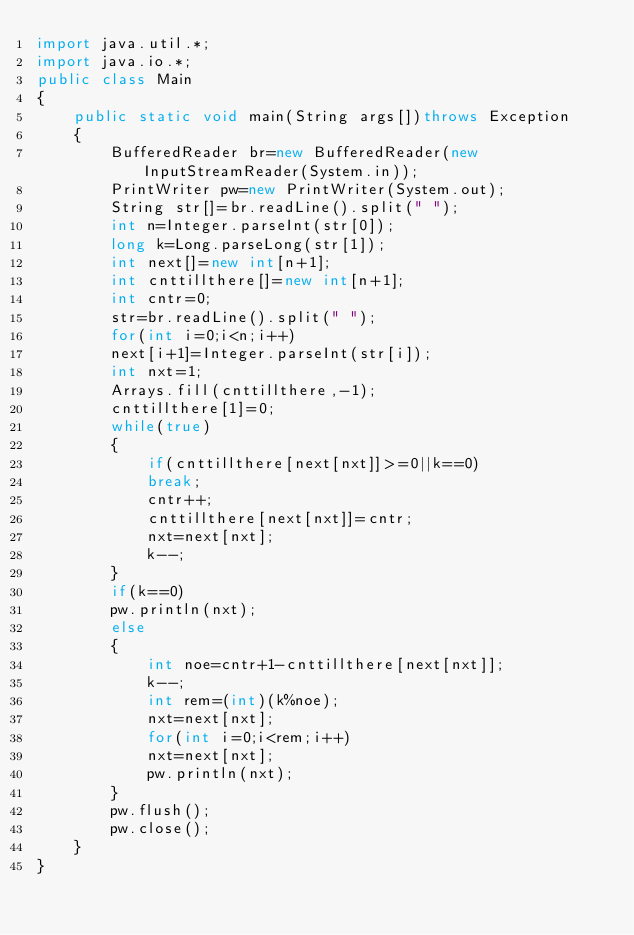Convert code to text. <code><loc_0><loc_0><loc_500><loc_500><_Java_>import java.util.*;
import java.io.*;
public class Main
{
    public static void main(String args[])throws Exception
    {
        BufferedReader br=new BufferedReader(new InputStreamReader(System.in));
        PrintWriter pw=new PrintWriter(System.out);
        String str[]=br.readLine().split(" ");
        int n=Integer.parseInt(str[0]);
        long k=Long.parseLong(str[1]);
        int next[]=new int[n+1];
        int cnttillthere[]=new int[n+1];
        int cntr=0;
        str=br.readLine().split(" ");
        for(int i=0;i<n;i++)
        next[i+1]=Integer.parseInt(str[i]);
        int nxt=1;
        Arrays.fill(cnttillthere,-1);
        cnttillthere[1]=0;
        while(true)
        {
            if(cnttillthere[next[nxt]]>=0||k==0)
            break;
            cntr++;
            cnttillthere[next[nxt]]=cntr;
            nxt=next[nxt];
            k--;
        }
        if(k==0)
        pw.println(nxt);
        else
        {
            int noe=cntr+1-cnttillthere[next[nxt]];
            k--;
            int rem=(int)(k%noe);
            nxt=next[nxt];
            for(int i=0;i<rem;i++)
            nxt=next[nxt];
            pw.println(nxt);
        }
        pw.flush();
        pw.close();
    }
}</code> 